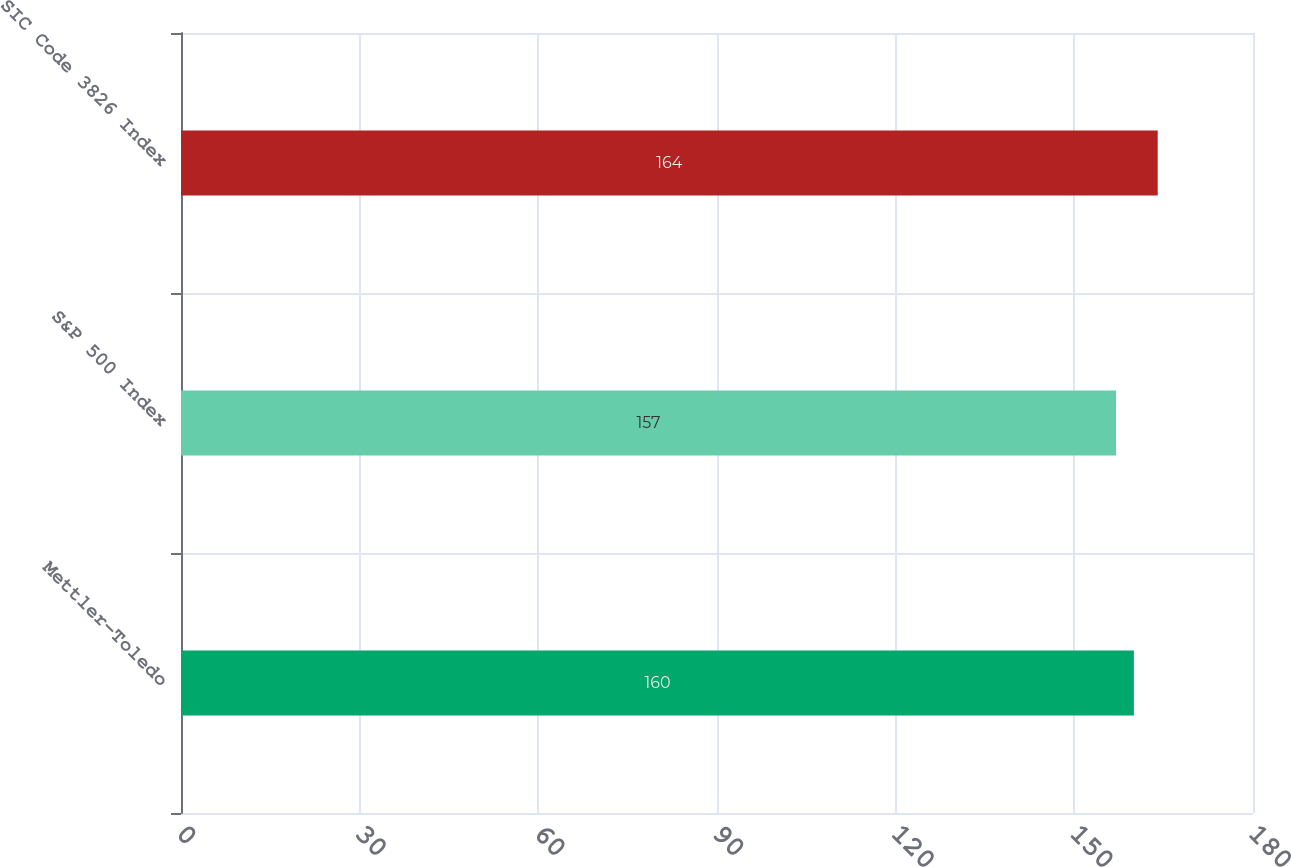Convert chart to OTSL. <chart><loc_0><loc_0><loc_500><loc_500><bar_chart><fcel>Mettler-Toledo<fcel>S&P 500 Index<fcel>SIC Code 3826 Index<nl><fcel>160<fcel>157<fcel>164<nl></chart> 